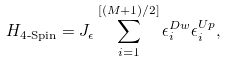<formula> <loc_0><loc_0><loc_500><loc_500>H _ { \text {4-Spin} } = J _ { \epsilon } \sum _ { i = 1 } ^ { [ ( M + 1 ) / 2 ] } \epsilon _ { i } ^ { D w } \epsilon _ { i } ^ { U p } ,</formula> 